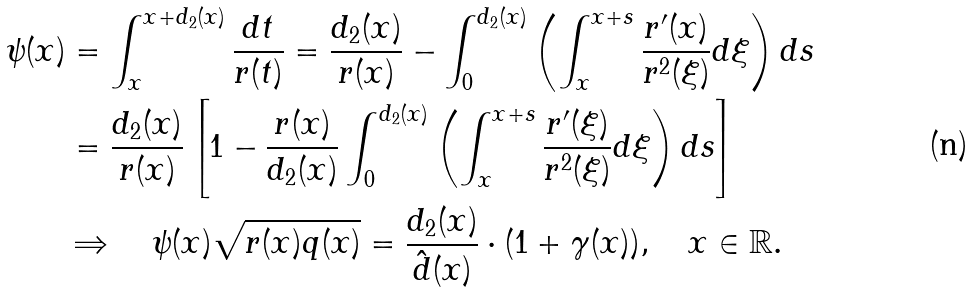<formula> <loc_0><loc_0><loc_500><loc_500>\psi ( x ) & = \int _ { x } ^ { x + d _ { 2 } ( x ) } \frac { d t } { r ( t ) } = \frac { d _ { 2 } ( x ) } { r ( x ) } - \int _ { 0 } ^ { d _ { 2 } ( x ) } \left ( \int _ { x } ^ { x + s } \frac { r ^ { \prime } ( x ) } { r ^ { 2 } ( \xi ) } d \xi \right ) d s \\ & = \frac { d _ { 2 } ( x ) } { r ( x ) } \left [ 1 - \frac { r ( x ) } { d _ { 2 } ( x ) } \int _ { 0 } ^ { d _ { 2 } ( x ) } \left ( \int _ { x } ^ { x + s } \frac { r ^ { \prime } ( \xi ) } { r ^ { 2 } ( \xi ) } d \xi \right ) d s \right ] \\ & \Rightarrow \quad \psi ( x ) \sqrt { r ( x ) q ( x ) } = \frac { d _ { 2 } ( x ) } { \hat { d } ( x ) } \cdot ( 1 + \gamma ( x ) ) , \quad x \in \mathbb { R } .</formula> 